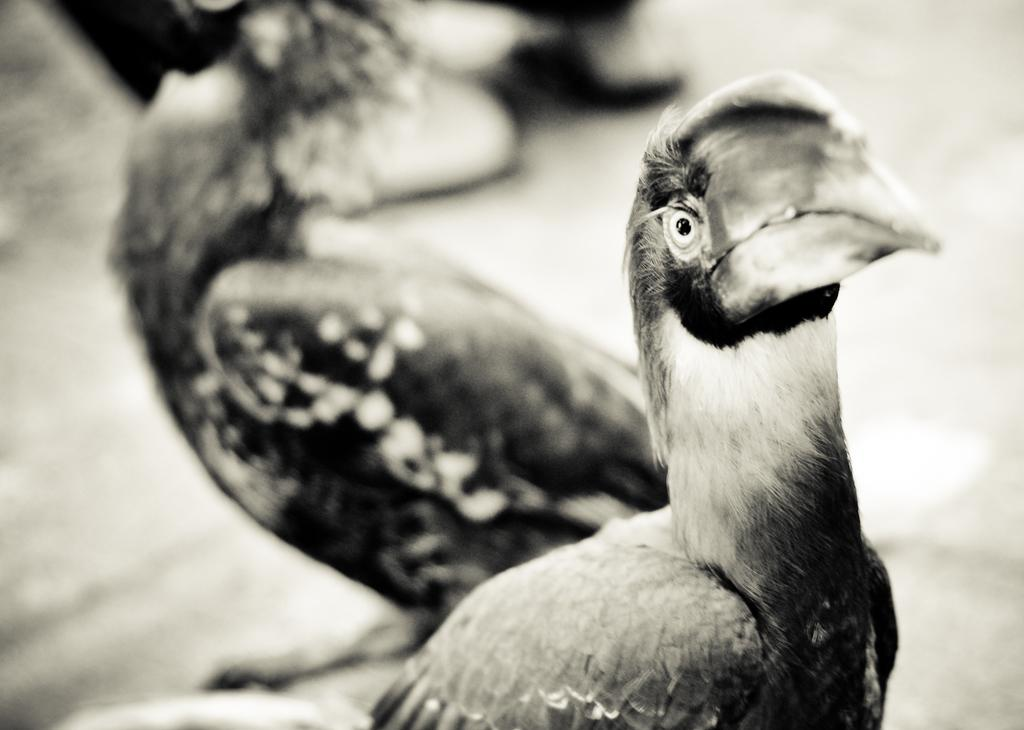What type of animals can be seen in the image? Birds can be seen in the image. What is the color scheme of the image? The image is black and white. What type of stamp can be seen on the birds in the image? There is no stamp present on the birds in the image; they are not depicted with any markings or labels. 